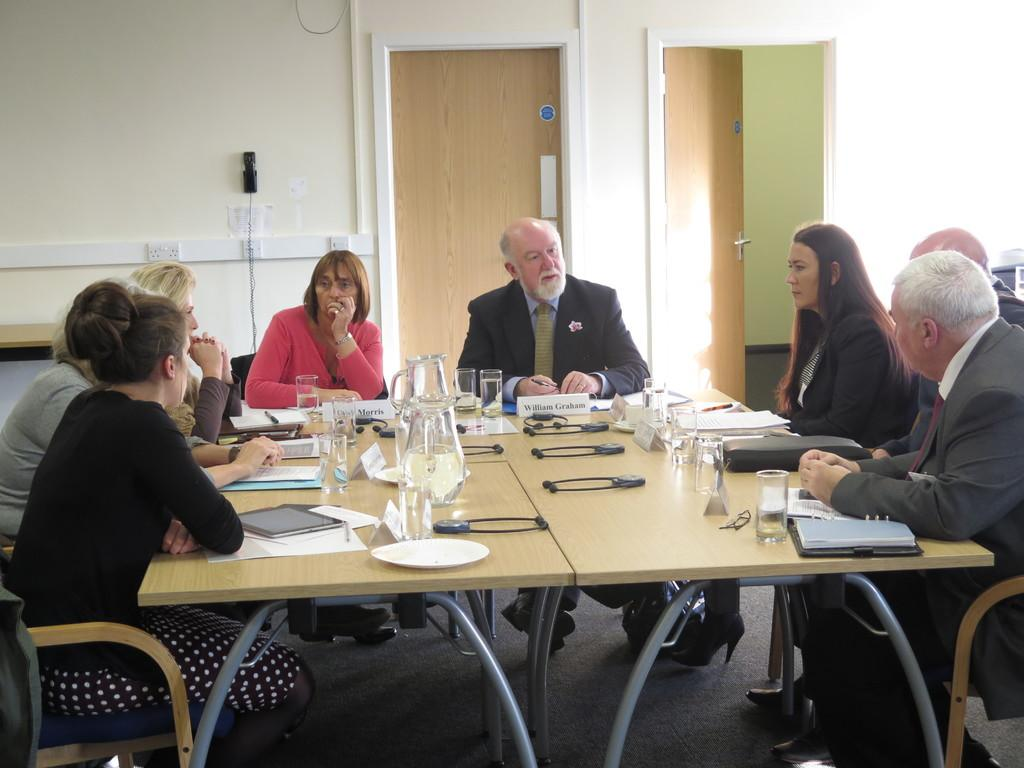What are the people in the image doing? The people in the image are sitting on chairs at a table. What items can be seen on the table? There are books, plates, glasses, and jugs on the table. Is there any communication device visible in the image? Yes, there is a phone on the wall. What type of stew is being served in the image? There is no stew present in the image; the table contains books, plates, glasses, and jugs. How many bikes are parked near the table in the image? There are no bikes visible in the image; it only shows people sitting at a table with various items. 